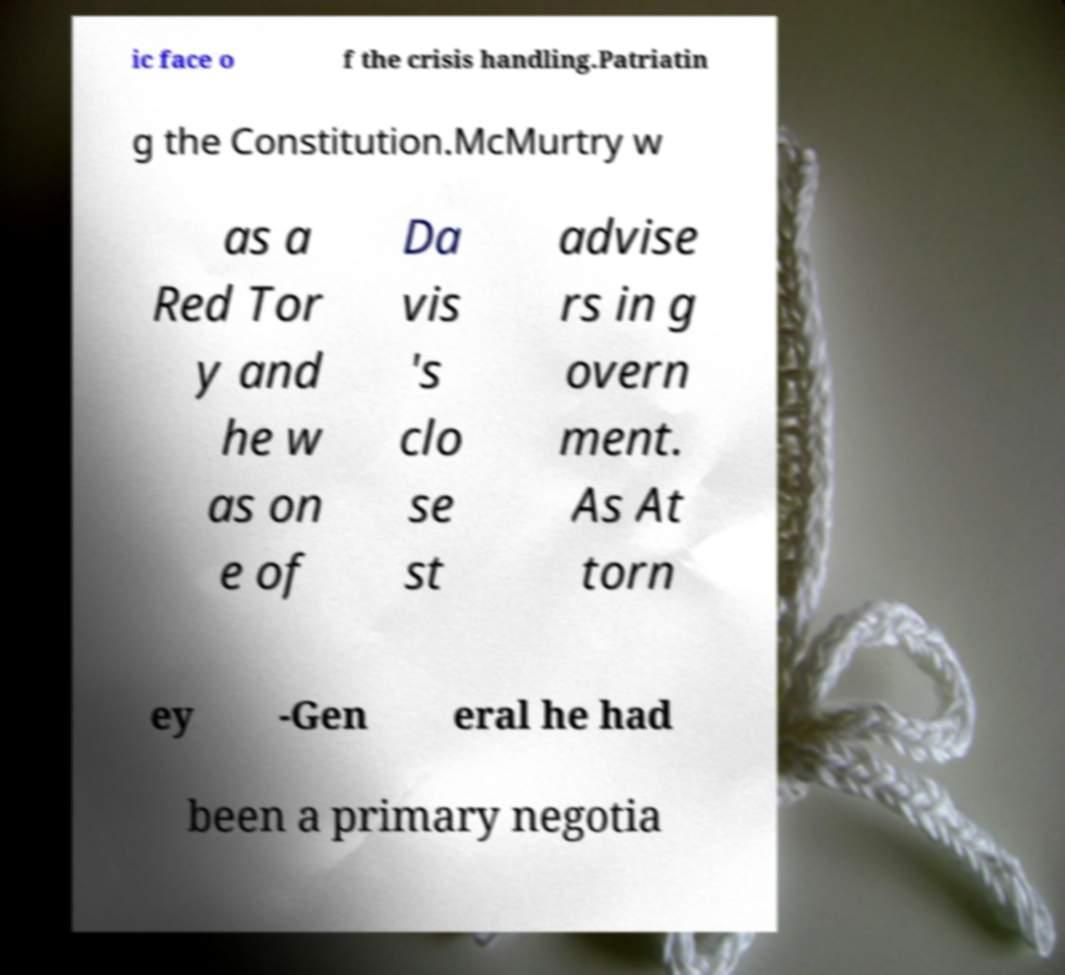There's text embedded in this image that I need extracted. Can you transcribe it verbatim? ic face o f the crisis handling.Patriatin g the Constitution.McMurtry w as a Red Tor y and he w as on e of Da vis 's clo se st advise rs in g overn ment. As At torn ey -Gen eral he had been a primary negotia 